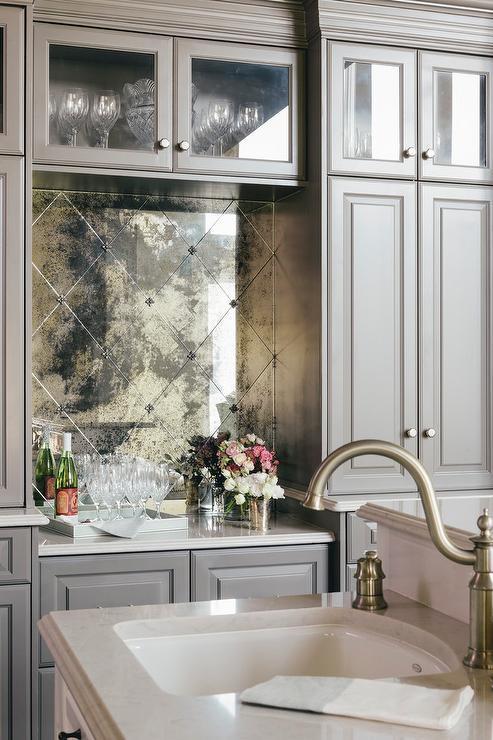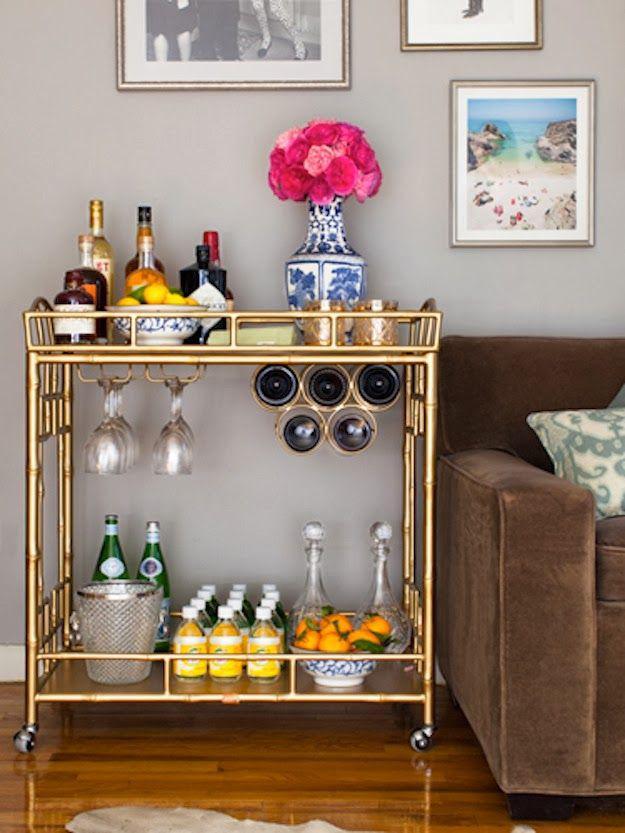The first image is the image on the left, the second image is the image on the right. Examine the images to the left and right. Is the description "In at least one image there is a brown chair next to a homemade bar." accurate? Answer yes or no. Yes. The first image is the image on the left, the second image is the image on the right. Analyze the images presented: Is the assertion "At least one wine bottle is being stored horizontally in a rack." valid? Answer yes or no. Yes. 